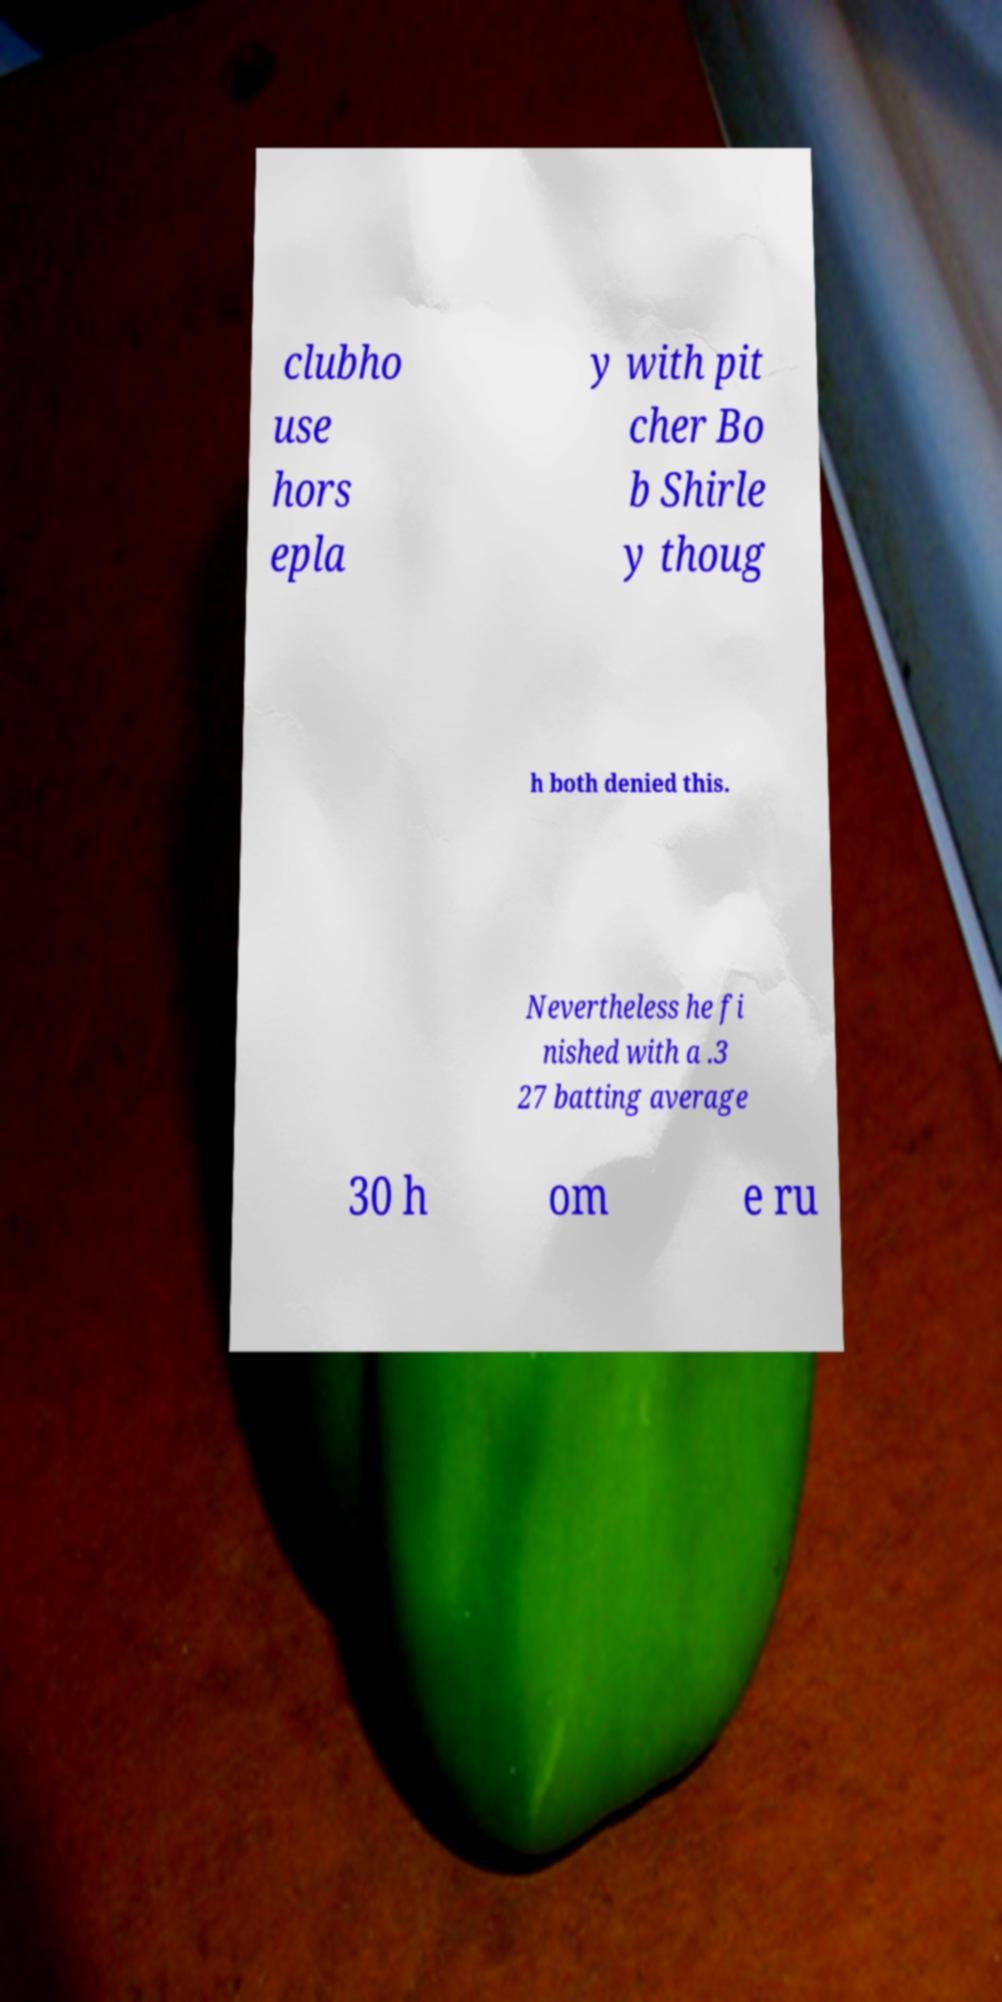Could you assist in decoding the text presented in this image and type it out clearly? clubho use hors epla y with pit cher Bo b Shirle y thoug h both denied this. Nevertheless he fi nished with a .3 27 batting average 30 h om e ru 